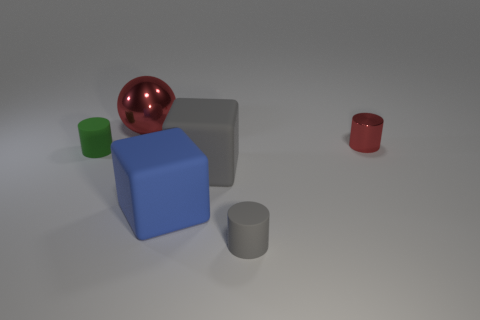What materials do the objects in the image appear to be made from? The objects in the image appear to be rendered with different materials. The red and green objects seem to have a matte finish suggesting a plastic or painted wood material. In contrast, the larger blue cube has a more solid and slightly reflective surface, which could imply a metallic or polished stone finish. 